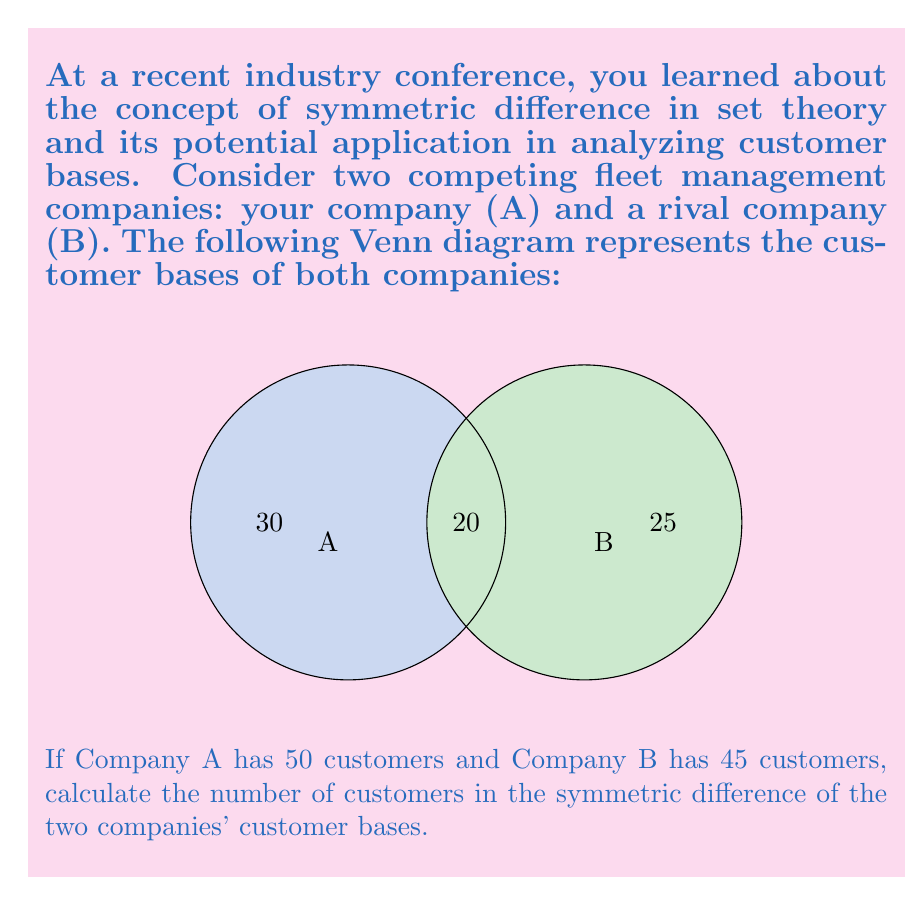Solve this math problem. Let's approach this step-by-step:

1) First, let's recall the definition of symmetric difference:
   The symmetric difference of two sets A and B, denoted by $A \triangle B$, is the set of elements that are in either A or B, but not in both.

2) From the Venn diagram, we can see:
   - 30 customers are exclusive to Company A
   - 20 customers are shared by both companies
   - 25 customers are exclusive to Company B

3) The symmetric difference includes customers exclusive to A and customers exclusive to B:
   $|A \triangle B| = |A \setminus B| + |B \setminus A|$

4) From the diagram:
   $|A \setminus B| = 30$
   $|B \setminus A| = 25$

5) Therefore:
   $|A \triangle B| = 30 + 25 = 55$

6) We can verify this result using the given total customer numbers:
   Company A total: $30 + 20 = 50$
   Company B total: $20 + 25 = 45$
   
   This matches the information given in the question.

Thus, the symmetric difference contains 55 customers.
Answer: 55 customers 